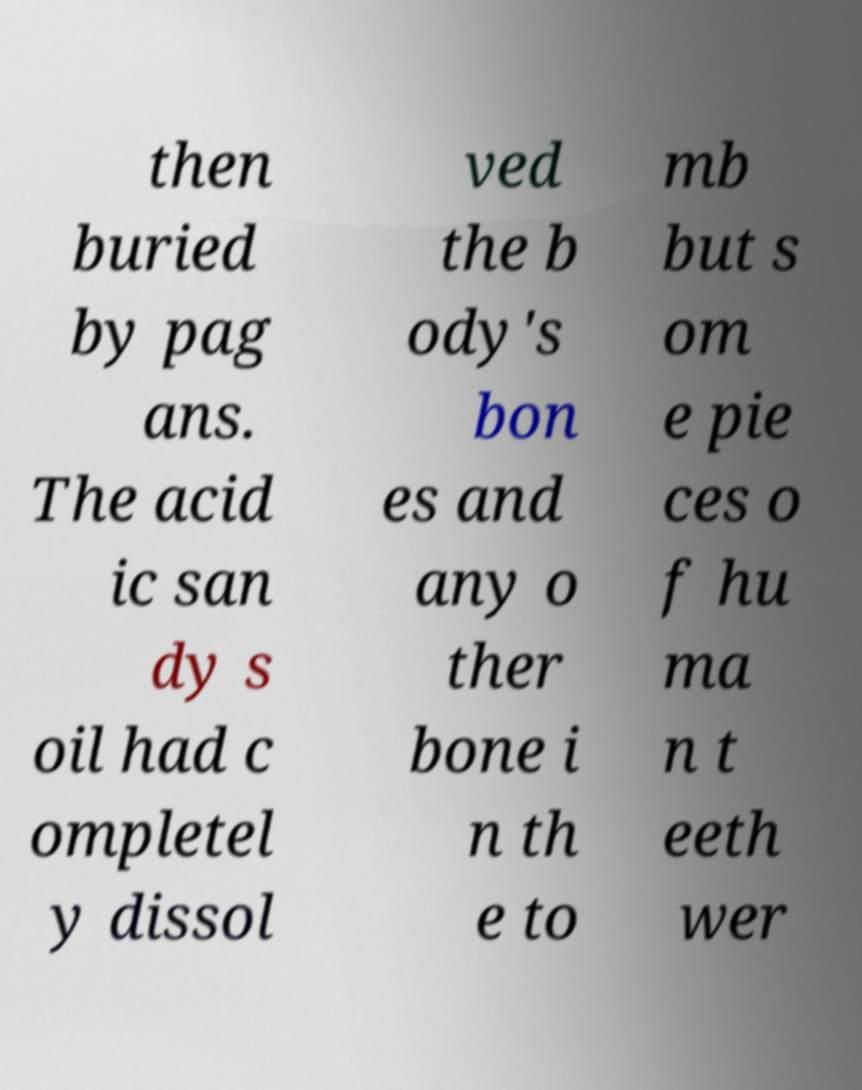I need the written content from this picture converted into text. Can you do that? then buried by pag ans. The acid ic san dy s oil had c ompletel y dissol ved the b ody's bon es and any o ther bone i n th e to mb but s om e pie ces o f hu ma n t eeth wer 